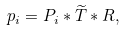Convert formula to latex. <formula><loc_0><loc_0><loc_500><loc_500>p _ { i } = P _ { i } * \widetilde { T } * R ,</formula> 